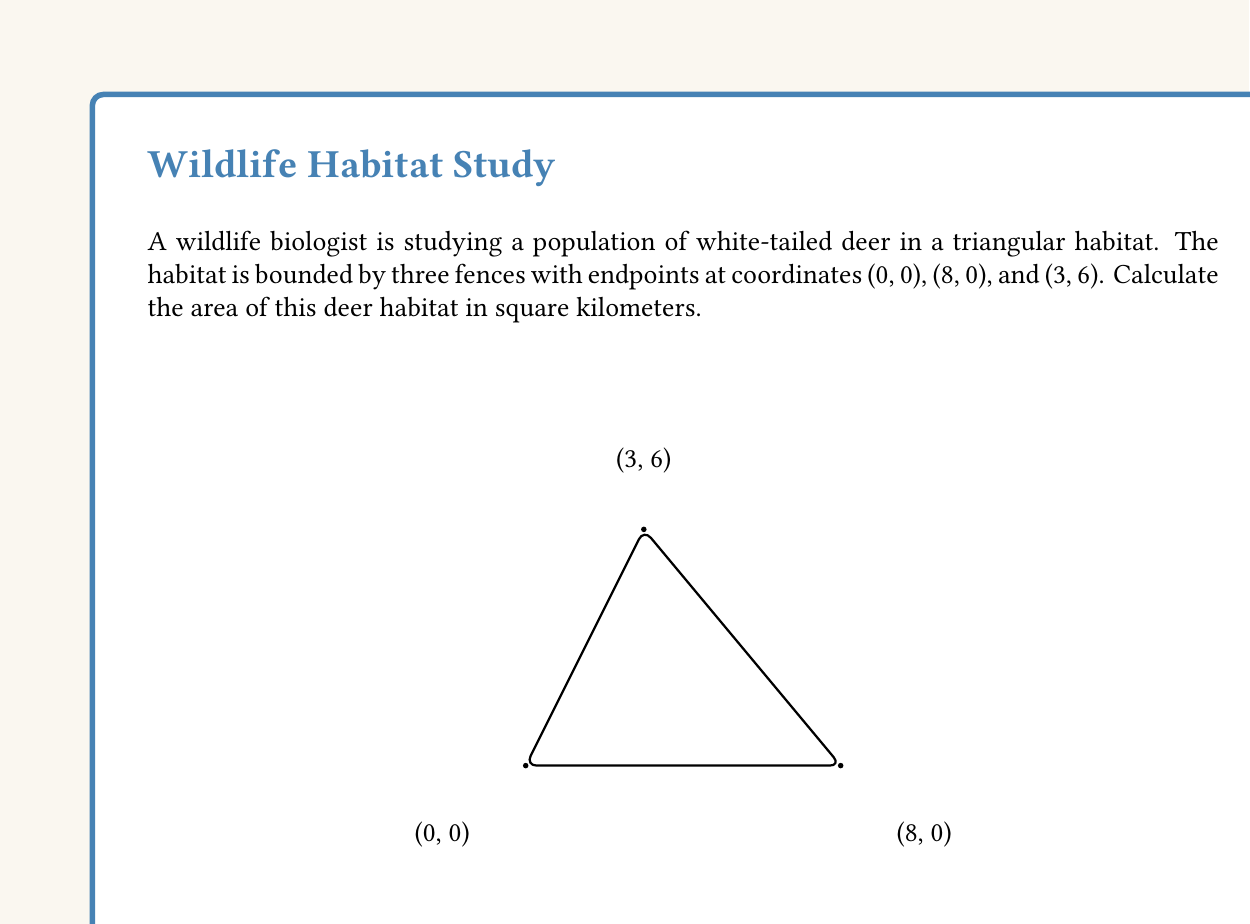Can you solve this math problem? To calculate the area of the triangular habitat, we can use the formula for the area of a triangle given the coordinates of its vertices:

$$A = \frac{1}{2}|x_1(y_2 - y_3) + x_2(y_3 - y_1) + x_3(y_1 - y_2)|$$

Where $(x_1, y_1)$, $(x_2, y_2)$, and $(x_3, y_3)$ are the coordinates of the three vertices.

Let's assign the coordinates:
$(x_1, y_1) = (0, 0)$
$(x_2, y_2) = (8, 0)$
$(x_3, y_3) = (3, 6)$

Now, let's substitute these values into the formula:

$$A = \frac{1}{2}|0(0 - 6) + 8(6 - 0) + 3(0 - 0)|$$

Simplifying:
$$A = \frac{1}{2}|0 + 48 + 0|$$
$$A = \frac{1}{2}(48)$$
$$A = 24$$

Therefore, the area of the deer habitat is 24 square kilometers.
Answer: 24 km² 